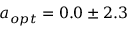<formula> <loc_0><loc_0><loc_500><loc_500>a _ { o p t } = 0 . 0 \pm 2 . 3</formula> 